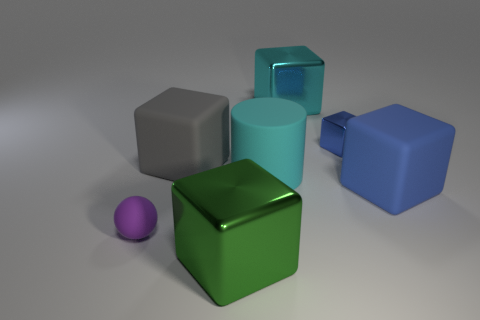Are the colors of the objects based on standard color theory principles for shading and reflections? The objects' colors appear to represent a simple exercise in three-dimensional rendering, showing basic shading and reflections, but they do not necessarily conform to a standard color theory principle; they are primarily used here to differentiate between the objects. 